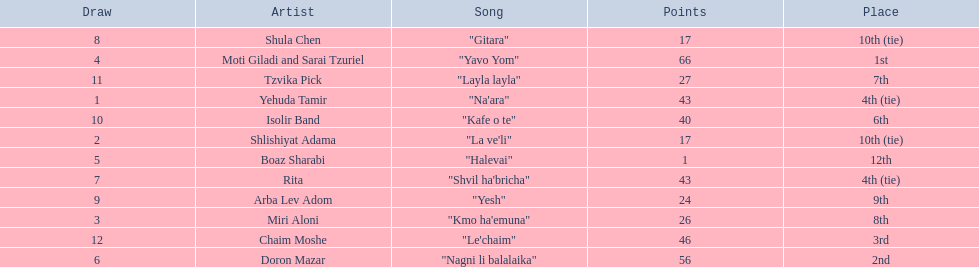What are the points? 43, 17, 26, 66, 1, 56, 43, 17, 24, 40, 27, 46. What is the least? 1. Which artist has that much Boaz Sharabi. 